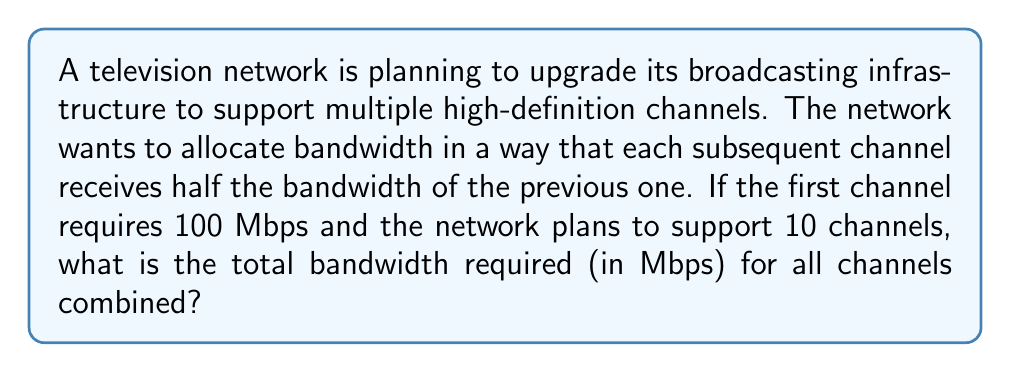Provide a solution to this math problem. Let's approach this step-by-step using the concept of harmonic series:

1) The bandwidth allocation follows this pattern:
   Channel 1: 100 Mbps
   Channel 2: 50 Mbps
   Channel 3: 25 Mbps
   ...and so on.

2) This forms a geometric sequence with first term $a = 100$ and common ratio $r = \frac{1}{2}$.

3) The sum of this geometric sequence for 10 terms is given by the formula:
   $$S = \frac{a(1-r^n)}{1-r}$$
   where $S$ is the sum, $a$ is the first term, $r$ is the common ratio, and $n$ is the number of terms.

4) Substituting our values:
   $$S = \frac{100(1-(\frac{1}{2})^{10})}{1-\frac{1}{2}}$$

5) Simplify:
   $$S = \frac{100(1-\frac{1}{1024})}{0.5}$$

6) Calculate:
   $$S = 200(1-\frac{1}{1024}) = 200(\frac{1023}{1024})$$

7) Final calculation:
   $$S = \frac{200 \times 1023}{1024} \approx 199.8046875$$

Therefore, the total bandwidth required for all 10 channels is approximately 199.8046875 Mbps.
Answer: 199.8046875 Mbps 